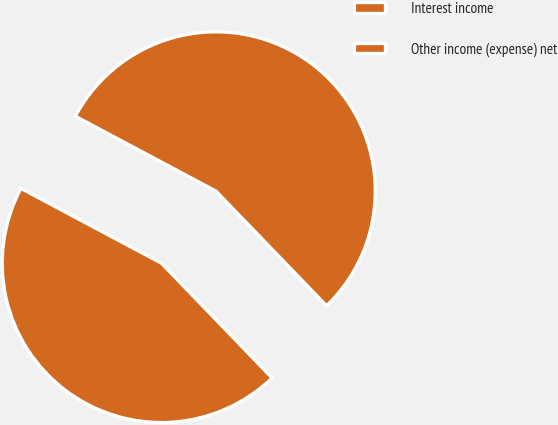Convert chart to OTSL. <chart><loc_0><loc_0><loc_500><loc_500><pie_chart><fcel>Interest income<fcel>Other income (expense) net<nl><fcel>45.0%<fcel>55.0%<nl></chart> 